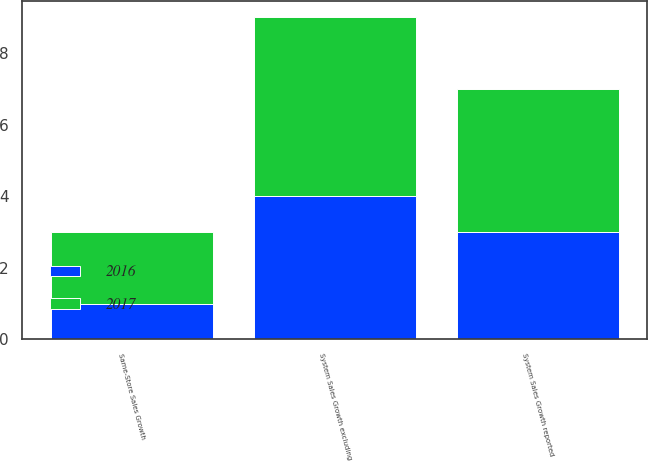<chart> <loc_0><loc_0><loc_500><loc_500><stacked_bar_chart><ecel><fcel>System Sales Growth reported<fcel>System Sales Growth excluding<fcel>Same-Store Sales Growth<nl><fcel>2017<fcel>4<fcel>5<fcel>2<nl><fcel>2016<fcel>3<fcel>4<fcel>1<nl></chart> 